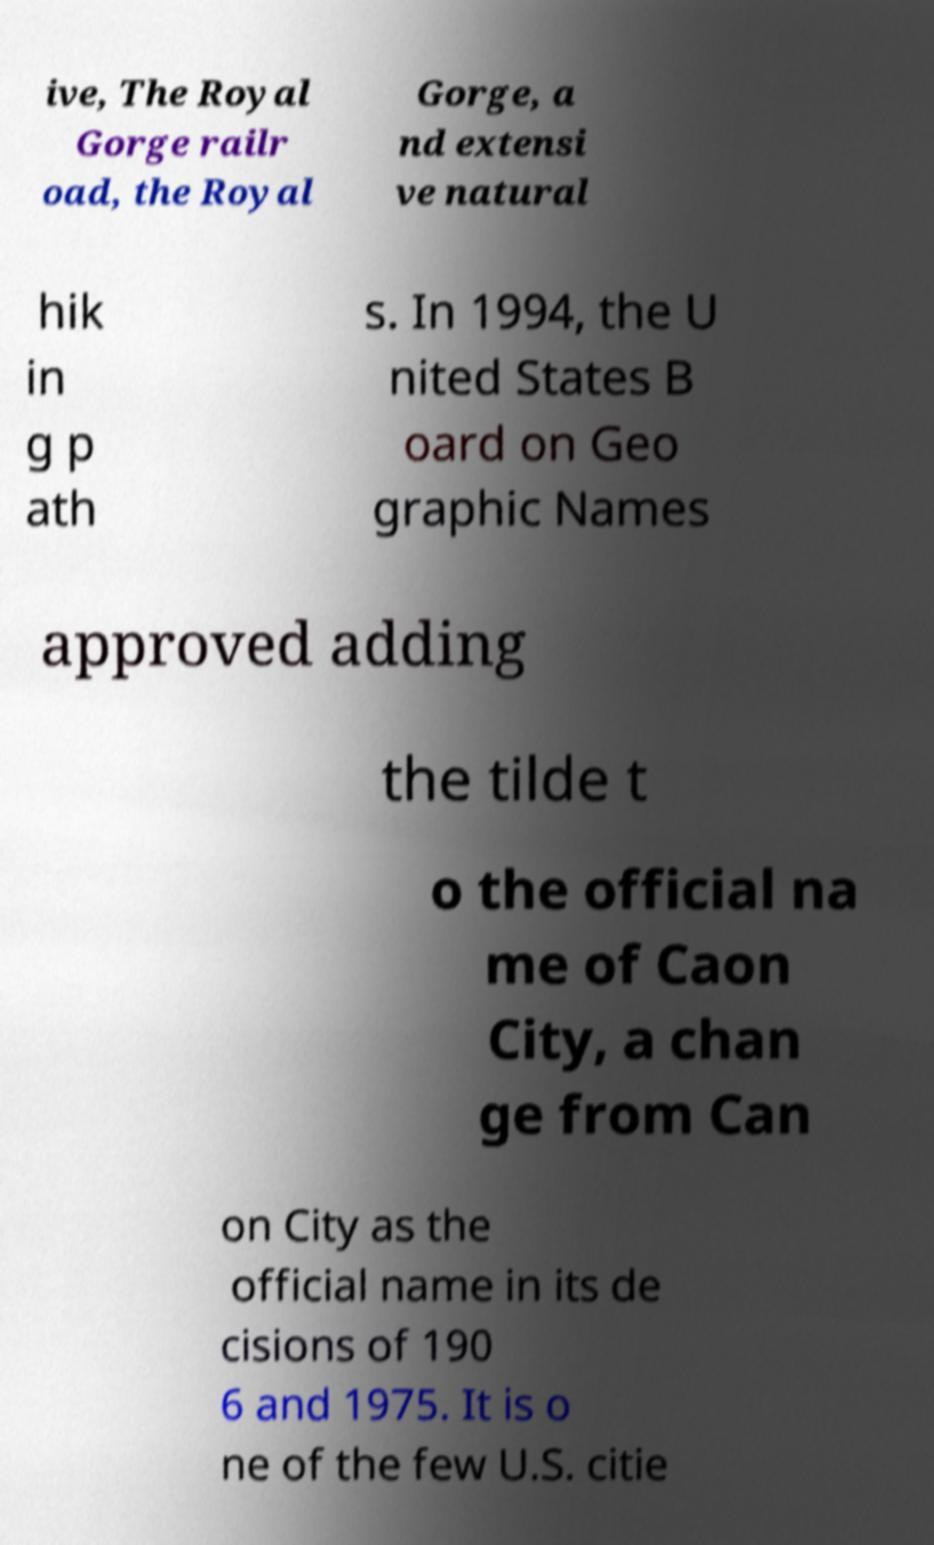Could you assist in decoding the text presented in this image and type it out clearly? ive, The Royal Gorge railr oad, the Royal Gorge, a nd extensi ve natural hik in g p ath s. In 1994, the U nited States B oard on Geo graphic Names approved adding the tilde t o the official na me of Caon City, a chan ge from Can on City as the official name in its de cisions of 190 6 and 1975. It is o ne of the few U.S. citie 